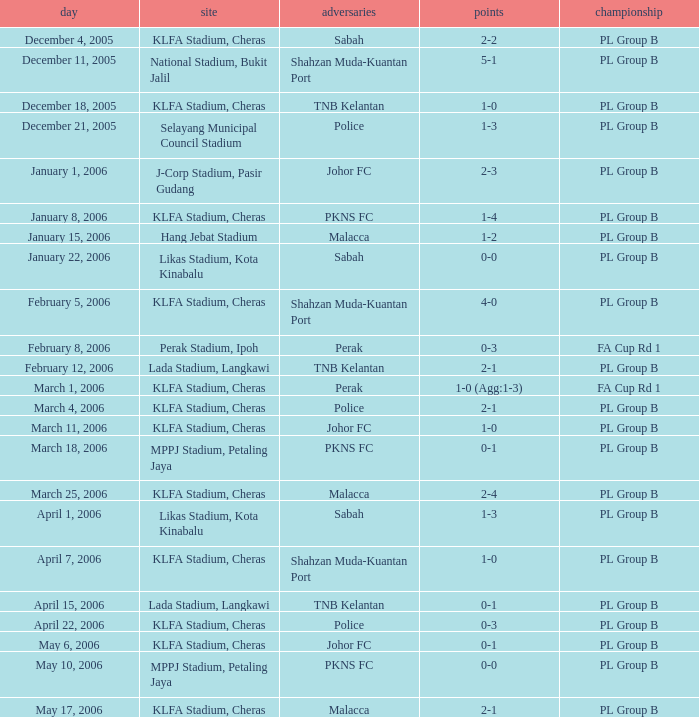Which Score has Opponents of pkns fc, and a Date of january 8, 2006? 1-4. 